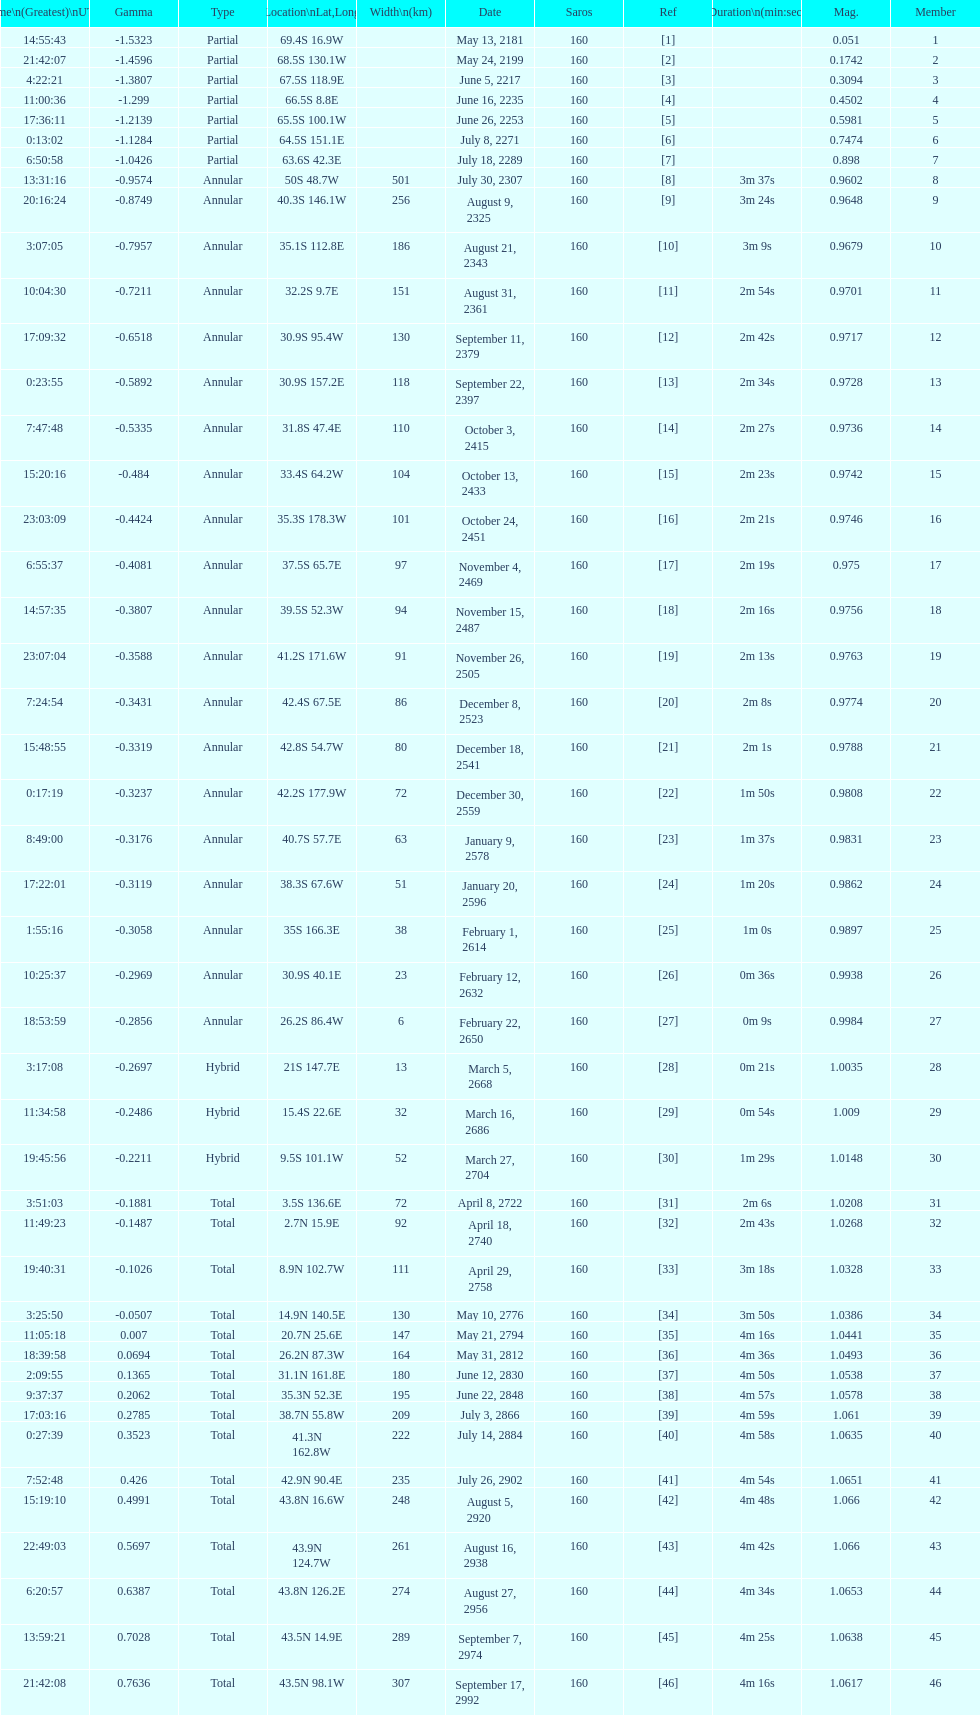When will the next solar saros be after the may 24, 2199 solar saros occurs? June 5, 2217. 